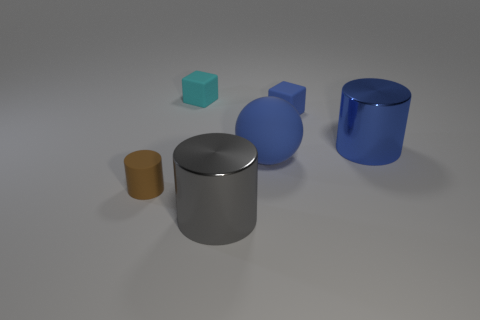Add 3 rubber blocks. How many objects exist? 9 Subtract all spheres. How many objects are left? 5 Subtract 0 purple balls. How many objects are left? 6 Subtract all cyan blocks. Subtract all large blue rubber objects. How many objects are left? 4 Add 5 tiny matte blocks. How many tiny matte blocks are left? 7 Add 2 large blue shiny cylinders. How many large blue shiny cylinders exist? 3 